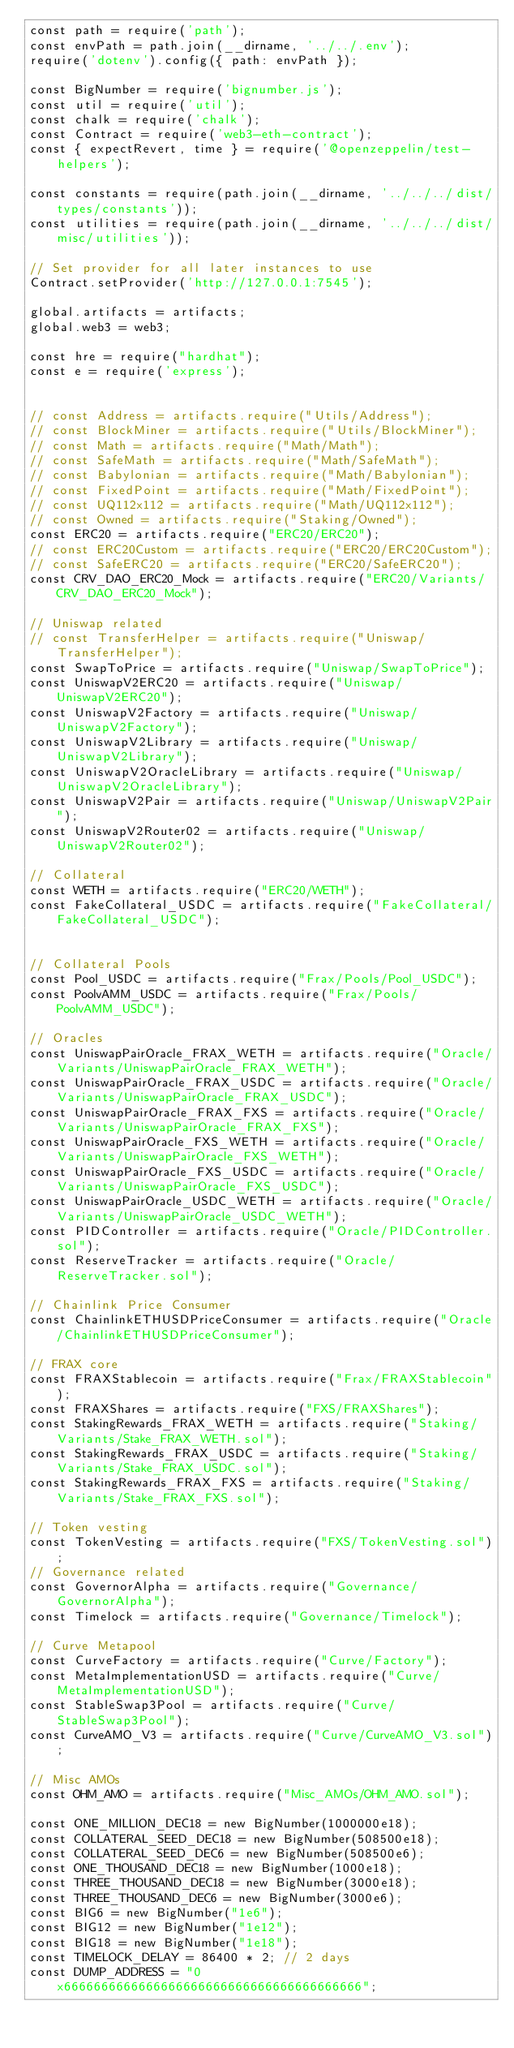<code> <loc_0><loc_0><loc_500><loc_500><_JavaScript_>const path = require('path');
const envPath = path.join(__dirname, '../../.env');
require('dotenv').config({ path: envPath });

const BigNumber = require('bignumber.js');
const util = require('util');
const chalk = require('chalk');
const Contract = require('web3-eth-contract');
const { expectRevert, time } = require('@openzeppelin/test-helpers');

const constants = require(path.join(__dirname, '../../../dist/types/constants'));
const utilities = require(path.join(__dirname, '../../../dist/misc/utilities'));

// Set provider for all later instances to use
Contract.setProvider('http://127.0.0.1:7545');

global.artifacts = artifacts;
global.web3 = web3;

const hre = require("hardhat");
const e = require('express');


// const Address = artifacts.require("Utils/Address");
// const BlockMiner = artifacts.require("Utils/BlockMiner");
// const Math = artifacts.require("Math/Math");
// const SafeMath = artifacts.require("Math/SafeMath");
// const Babylonian = artifacts.require("Math/Babylonian");
// const FixedPoint = artifacts.require("Math/FixedPoint");
// const UQ112x112 = artifacts.require("Math/UQ112x112");
// const Owned = artifacts.require("Staking/Owned");
const ERC20 = artifacts.require("ERC20/ERC20");
// const ERC20Custom = artifacts.require("ERC20/ERC20Custom");
// const SafeERC20 = artifacts.require("ERC20/SafeERC20");
const CRV_DAO_ERC20_Mock = artifacts.require("ERC20/Variants/CRV_DAO_ERC20_Mock");

// Uniswap related
// const TransferHelper = artifacts.require("Uniswap/TransferHelper");
const SwapToPrice = artifacts.require("Uniswap/SwapToPrice");
const UniswapV2ERC20 = artifacts.require("Uniswap/UniswapV2ERC20");
const UniswapV2Factory = artifacts.require("Uniswap/UniswapV2Factory");
const UniswapV2Library = artifacts.require("Uniswap/UniswapV2Library");
const UniswapV2OracleLibrary = artifacts.require("Uniswap/UniswapV2OracleLibrary");
const UniswapV2Pair = artifacts.require("Uniswap/UniswapV2Pair");
const UniswapV2Router02 = artifacts.require("Uniswap/UniswapV2Router02");

// Collateral
const WETH = artifacts.require("ERC20/WETH");
const FakeCollateral_USDC = artifacts.require("FakeCollateral/FakeCollateral_USDC");


// Collateral Pools
const Pool_USDC = artifacts.require("Frax/Pools/Pool_USDC");
const PoolvAMM_USDC = artifacts.require("Frax/Pools/PoolvAMM_USDC");

// Oracles
const UniswapPairOracle_FRAX_WETH = artifacts.require("Oracle/Variants/UniswapPairOracle_FRAX_WETH");
const UniswapPairOracle_FRAX_USDC = artifacts.require("Oracle/Variants/UniswapPairOracle_FRAX_USDC");
const UniswapPairOracle_FRAX_FXS = artifacts.require("Oracle/Variants/UniswapPairOracle_FRAX_FXS");
const UniswapPairOracle_FXS_WETH = artifacts.require("Oracle/Variants/UniswapPairOracle_FXS_WETH");
const UniswapPairOracle_FXS_USDC = artifacts.require("Oracle/Variants/UniswapPairOracle_FXS_USDC");
const UniswapPairOracle_USDC_WETH = artifacts.require("Oracle/Variants/UniswapPairOracle_USDC_WETH");
const PIDController = artifacts.require("Oracle/PIDController.sol");
const ReserveTracker = artifacts.require("Oracle/ReserveTracker.sol");

// Chainlink Price Consumer
const ChainlinkETHUSDPriceConsumer = artifacts.require("Oracle/ChainlinkETHUSDPriceConsumer");

// FRAX core
const FRAXStablecoin = artifacts.require("Frax/FRAXStablecoin");
const FRAXShares = artifacts.require("FXS/FRAXShares");
const StakingRewards_FRAX_WETH = artifacts.require("Staking/Variants/Stake_FRAX_WETH.sol");
const StakingRewards_FRAX_USDC = artifacts.require("Staking/Variants/Stake_FRAX_USDC.sol");
const StakingRewards_FRAX_FXS = artifacts.require("Staking/Variants/Stake_FRAX_FXS.sol");

// Token vesting
const TokenVesting = artifacts.require("FXS/TokenVesting.sol");
// Governance related
const GovernorAlpha = artifacts.require("Governance/GovernorAlpha");
const Timelock = artifacts.require("Governance/Timelock");

// Curve Metapool
const CurveFactory = artifacts.require("Curve/Factory");
const MetaImplementationUSD = artifacts.require("Curve/MetaImplementationUSD");
const StableSwap3Pool = artifacts.require("Curve/StableSwap3Pool");
const CurveAMO_V3 = artifacts.require("Curve/CurveAMO_V3.sol");

// Misc AMOs
const OHM_AMO = artifacts.require("Misc_AMOs/OHM_AMO.sol");

const ONE_MILLION_DEC18 = new BigNumber(1000000e18);
const COLLATERAL_SEED_DEC18 = new BigNumber(508500e18);
const COLLATERAL_SEED_DEC6 = new BigNumber(508500e6);
const ONE_THOUSAND_DEC18 = new BigNumber(1000e18);
const THREE_THOUSAND_DEC18 = new BigNumber(3000e18);
const THREE_THOUSAND_DEC6 = new BigNumber(3000e6);
const BIG6 = new BigNumber("1e6");
const BIG12 = new BigNumber("1e12");
const BIG18 = new BigNumber("1e18");
const TIMELOCK_DELAY = 86400 * 2; // 2 days
const DUMP_ADDRESS = "0x6666666666666666666666666666666666666666";</code> 